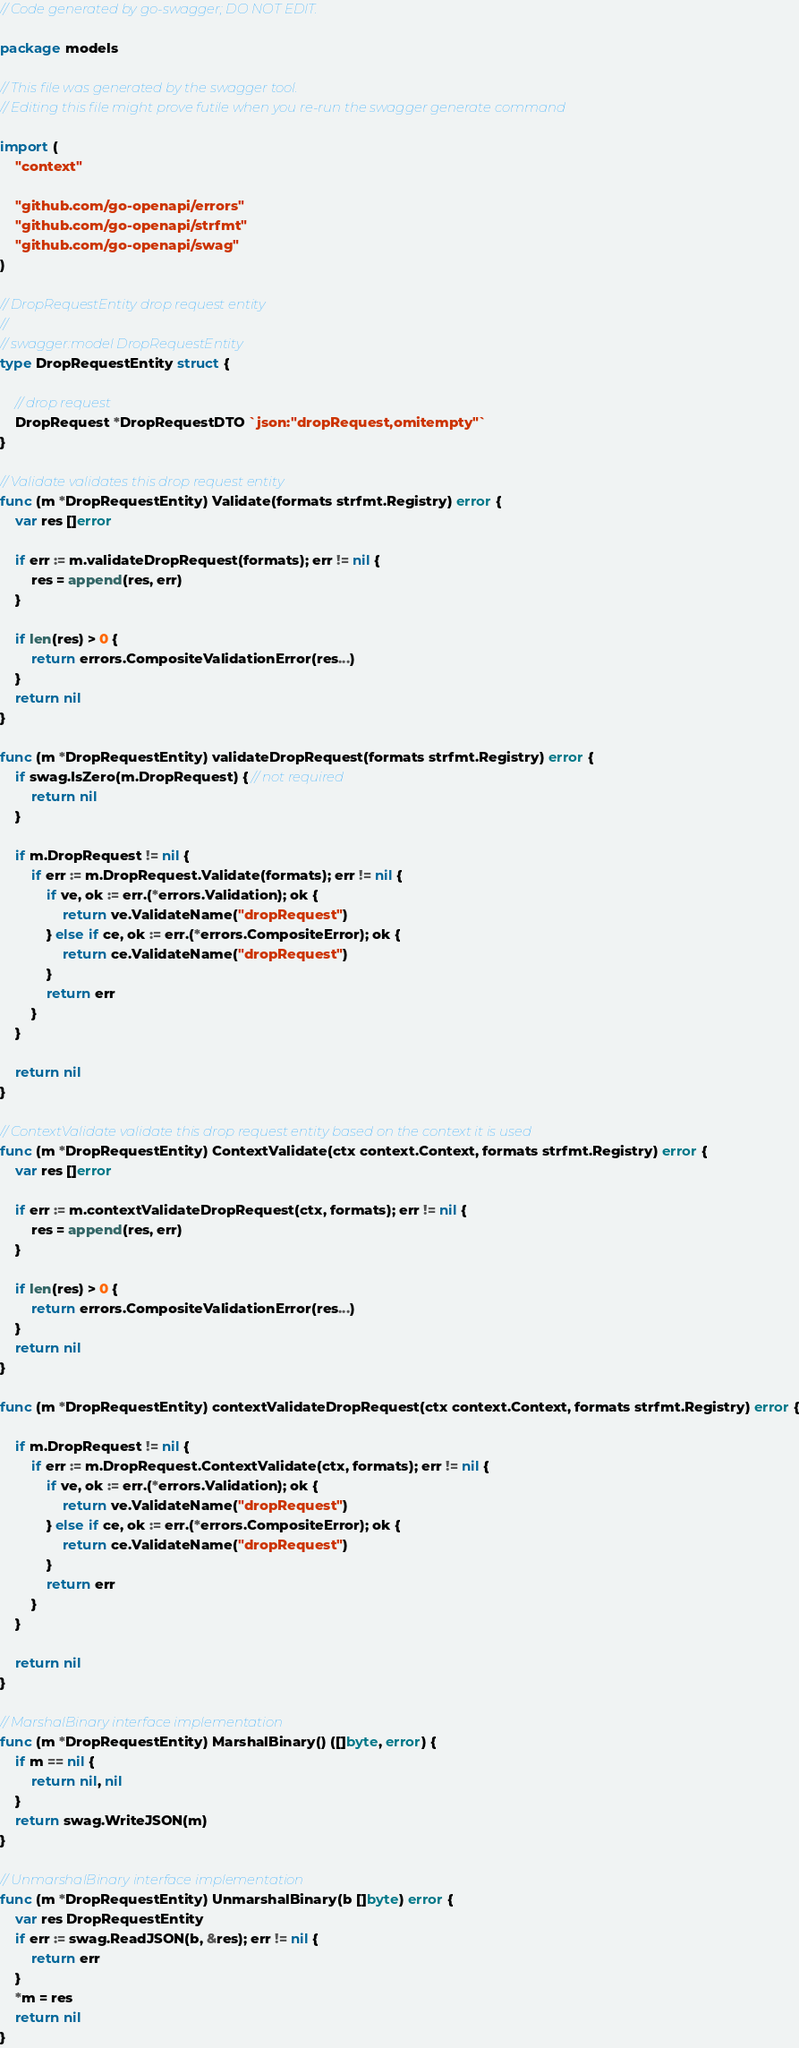Convert code to text. <code><loc_0><loc_0><loc_500><loc_500><_Go_>// Code generated by go-swagger; DO NOT EDIT.

package models

// This file was generated by the swagger tool.
// Editing this file might prove futile when you re-run the swagger generate command

import (
	"context"

	"github.com/go-openapi/errors"
	"github.com/go-openapi/strfmt"
	"github.com/go-openapi/swag"
)

// DropRequestEntity drop request entity
//
// swagger:model DropRequestEntity
type DropRequestEntity struct {

	// drop request
	DropRequest *DropRequestDTO `json:"dropRequest,omitempty"`
}

// Validate validates this drop request entity
func (m *DropRequestEntity) Validate(formats strfmt.Registry) error {
	var res []error

	if err := m.validateDropRequest(formats); err != nil {
		res = append(res, err)
	}

	if len(res) > 0 {
		return errors.CompositeValidationError(res...)
	}
	return nil
}

func (m *DropRequestEntity) validateDropRequest(formats strfmt.Registry) error {
	if swag.IsZero(m.DropRequest) { // not required
		return nil
	}

	if m.DropRequest != nil {
		if err := m.DropRequest.Validate(formats); err != nil {
			if ve, ok := err.(*errors.Validation); ok {
				return ve.ValidateName("dropRequest")
			} else if ce, ok := err.(*errors.CompositeError); ok {
				return ce.ValidateName("dropRequest")
			}
			return err
		}
	}

	return nil
}

// ContextValidate validate this drop request entity based on the context it is used
func (m *DropRequestEntity) ContextValidate(ctx context.Context, formats strfmt.Registry) error {
	var res []error

	if err := m.contextValidateDropRequest(ctx, formats); err != nil {
		res = append(res, err)
	}

	if len(res) > 0 {
		return errors.CompositeValidationError(res...)
	}
	return nil
}

func (m *DropRequestEntity) contextValidateDropRequest(ctx context.Context, formats strfmt.Registry) error {

	if m.DropRequest != nil {
		if err := m.DropRequest.ContextValidate(ctx, formats); err != nil {
			if ve, ok := err.(*errors.Validation); ok {
				return ve.ValidateName("dropRequest")
			} else if ce, ok := err.(*errors.CompositeError); ok {
				return ce.ValidateName("dropRequest")
			}
			return err
		}
	}

	return nil
}

// MarshalBinary interface implementation
func (m *DropRequestEntity) MarshalBinary() ([]byte, error) {
	if m == nil {
		return nil, nil
	}
	return swag.WriteJSON(m)
}

// UnmarshalBinary interface implementation
func (m *DropRequestEntity) UnmarshalBinary(b []byte) error {
	var res DropRequestEntity
	if err := swag.ReadJSON(b, &res); err != nil {
		return err
	}
	*m = res
	return nil
}
</code> 